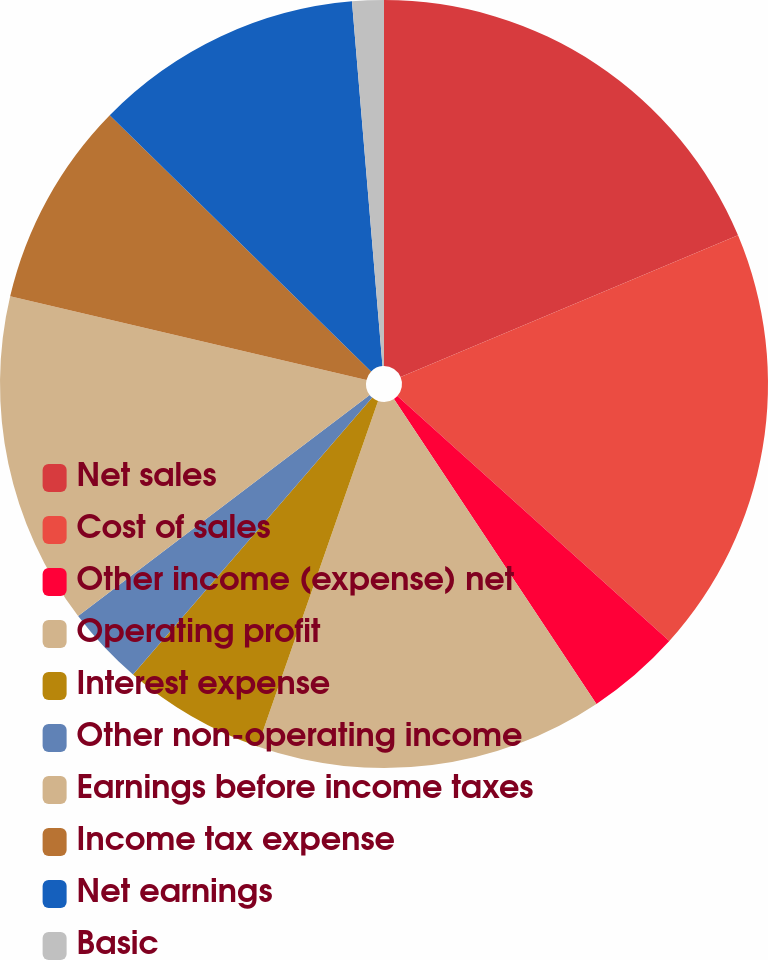Convert chart to OTSL. <chart><loc_0><loc_0><loc_500><loc_500><pie_chart><fcel>Net sales<fcel>Cost of sales<fcel>Other income (expense) net<fcel>Operating profit<fcel>Interest expense<fcel>Other non-operating income<fcel>Earnings before income taxes<fcel>Income tax expense<fcel>Net earnings<fcel>Basic<nl><fcel>18.67%<fcel>18.0%<fcel>4.0%<fcel>14.67%<fcel>6.0%<fcel>3.33%<fcel>14.0%<fcel>8.67%<fcel>11.33%<fcel>1.33%<nl></chart> 